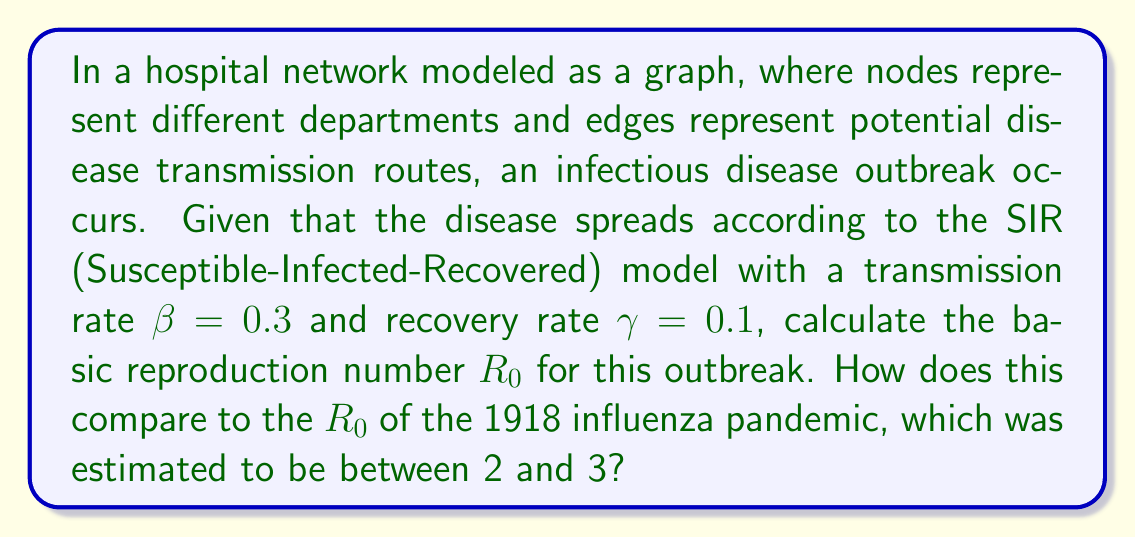Solve this math problem. To solve this problem, we need to understand the SIR model and the concept of the basic reproduction number $R_0$.

1. The SIR model is a compartmental model of infectious disease spread where:
   - S: Susceptible individuals
   - I: Infected individuals
   - R: Recovered individuals

2. The basic reproduction number $R_0$ is defined as the average number of secondary infections caused by one infected individual in a completely susceptible population.

3. In the SIR model, $R_0$ is calculated using the formula:

   $$R_0 = \frac{\beta}{\gamma}$$

   Where:
   - $\beta$ is the transmission rate
   - $\gamma$ is the recovery rate

4. Given:
   - $\beta = 0.3$
   - $\gamma = 0.1$

5. Substituting these values into the formula:

   $$R_0 = \frac{0.3}{0.1} = 3$$

6. Comparing to the 1918 influenza pandemic:
   - The calculated $R_0 = 3$ falls at the upper end of the estimated range (2-3) for the 1918 influenza pandemic.
   - This suggests that the current outbreak in the hospital network has a similar potential for spread as the historic pandemic, which was one of the most severe in recent history.

7. From a physician's perspective, this high $R_0$ value indicates:
   - The disease has a high potential for rapid spread within the hospital.
   - Strict infection control measures are necessary to contain the outbreak.
   - The importance of understanding how modern hospital networks can potentially amplify disease transmission compared to historical settings.
Answer: $R_0 = 3$, which is at the upper end of the estimated range for the 1918 influenza pandemic, indicating a similarly high potential for disease spread. 